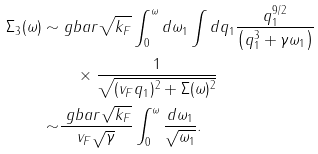Convert formula to latex. <formula><loc_0><loc_0><loc_500><loc_500>\Sigma _ { 3 } ( \omega ) \sim & \ g b a r \sqrt { k _ { F } } \int _ { 0 } ^ { \omega } d \omega _ { 1 } \int d q _ { 1 } \frac { q _ { 1 } ^ { 9 / 2 } } { \left ( q _ { 1 } ^ { 3 } + \gamma \omega _ { 1 } \right ) } \\ & \quad \times \frac { 1 } { \sqrt { ( v _ { F } q _ { 1 } ) ^ { 2 } + \Sigma ( \omega ) ^ { 2 } } } \\ \sim & \frac { \ g b a r \sqrt { k _ { F } } } { v _ { F } \sqrt { \gamma } } \int _ { 0 } ^ { \omega } \frac { d \omega _ { 1 } } { \sqrt { \omega _ { 1 } } } .</formula> 